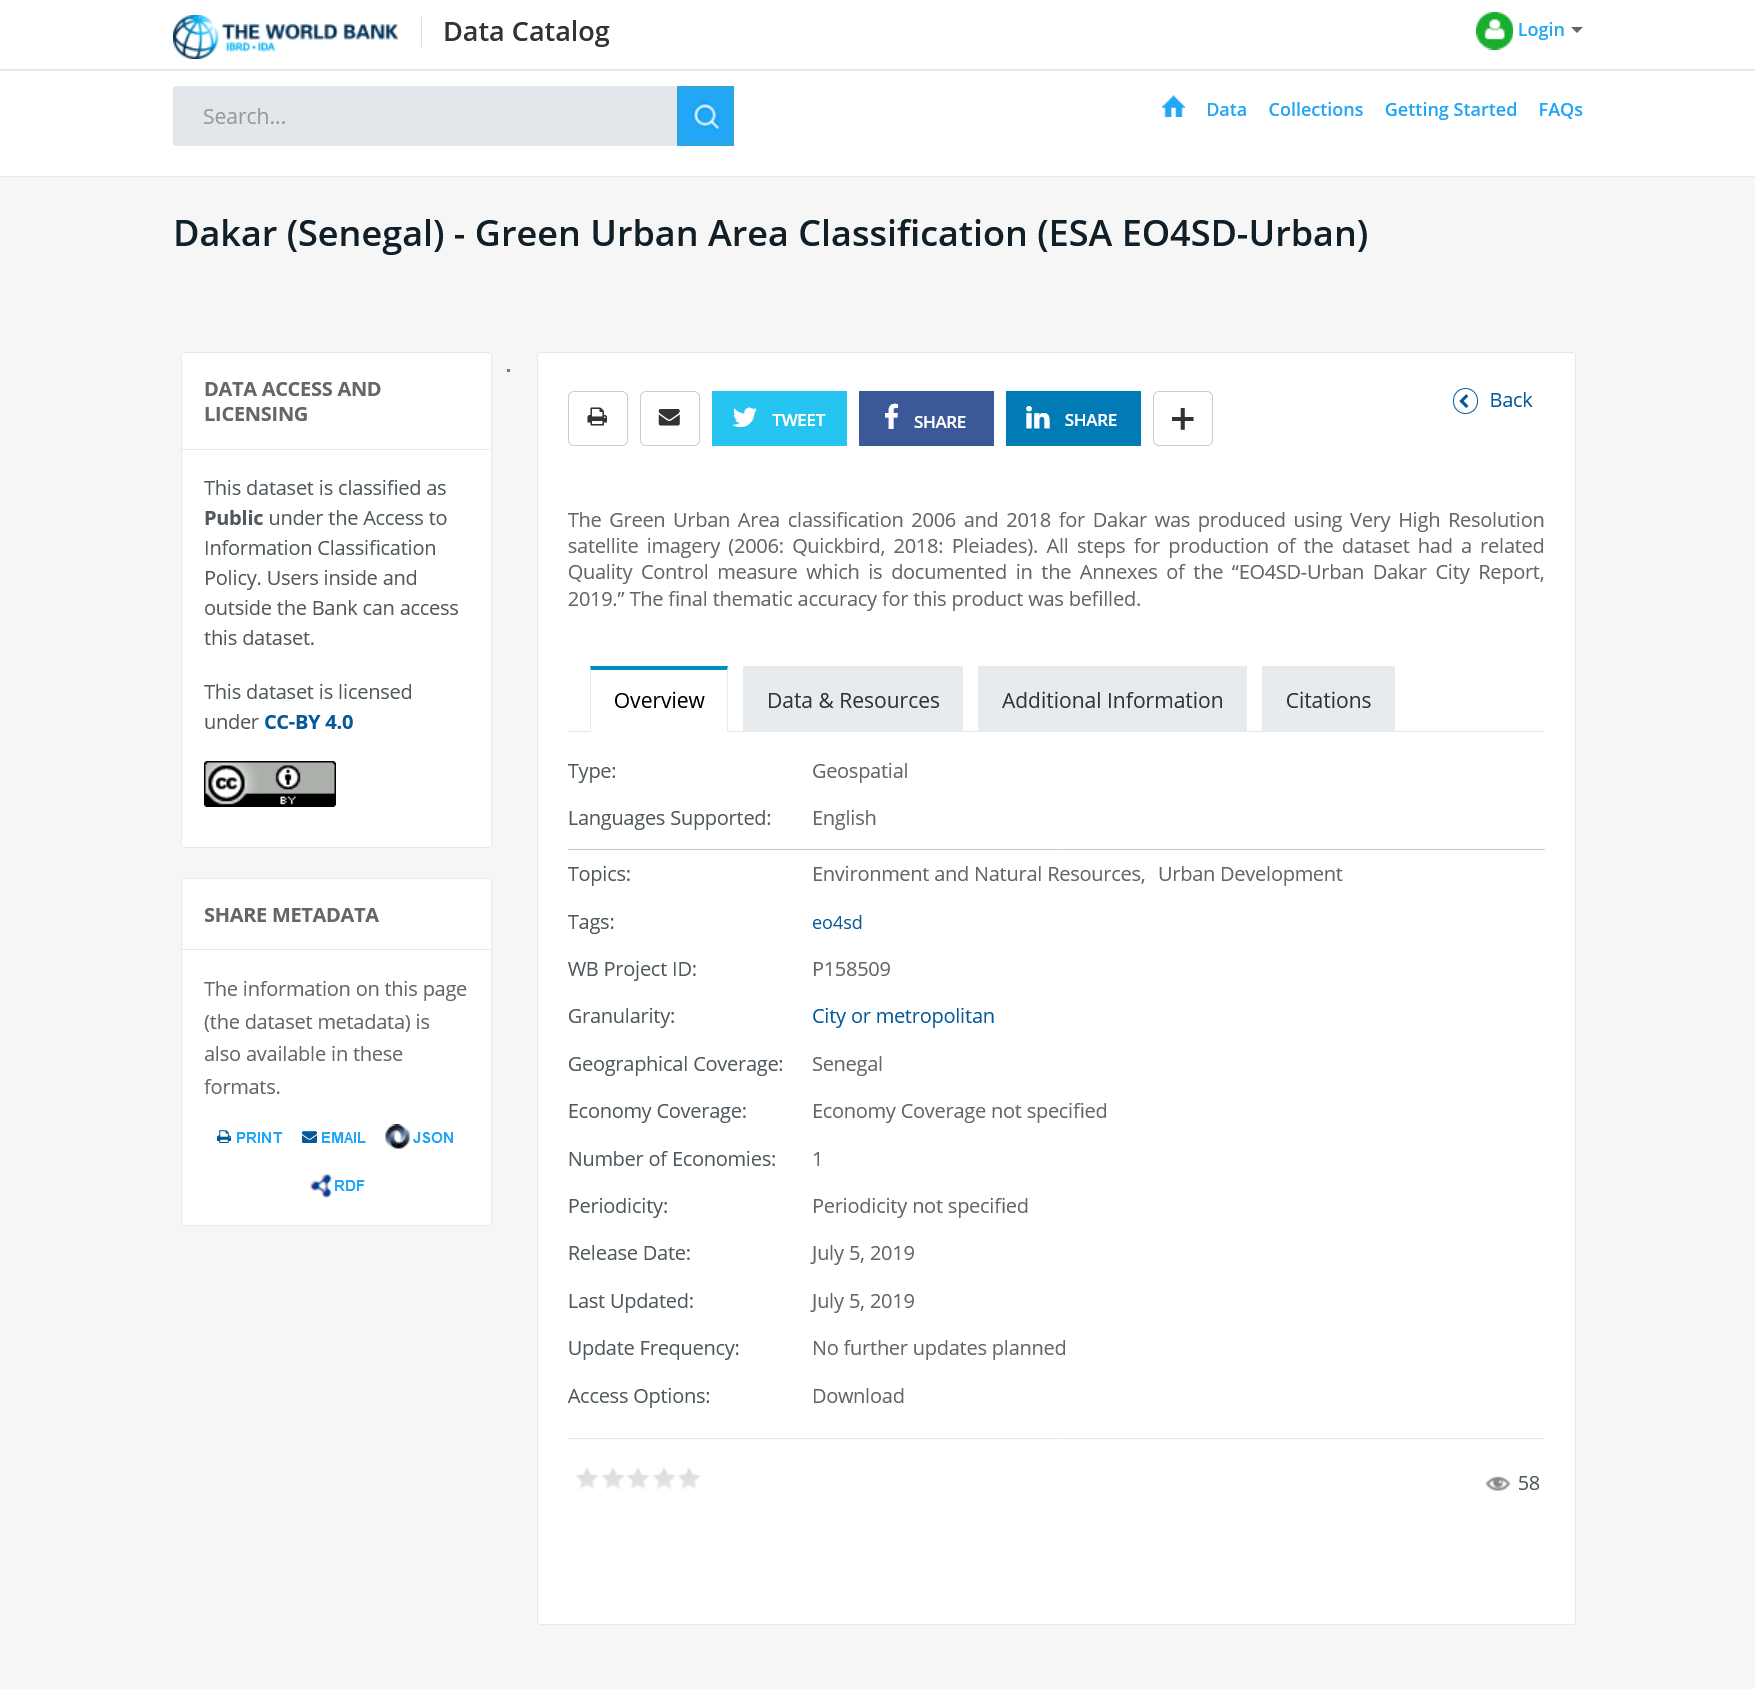Outline some significant characteristics in this image. This one can share by Facebook. The Green Urban Area Classification 2006 and 2018 for Dakar was produced using very high resolution satellite imagery. 